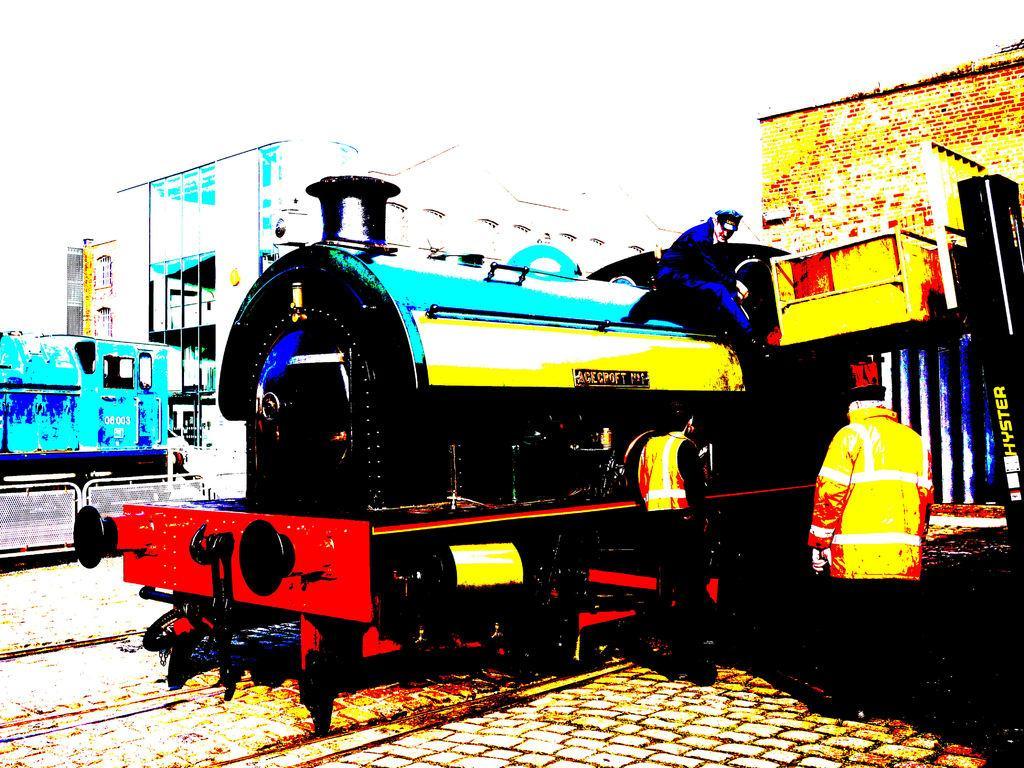Describe this image in one or two sentences. In this picture we can observe a train. There are two persons standing beside the train. This is a painting. We can observe red, blue and yellow colors. In the background there is a railway station. We can observe white color background. 